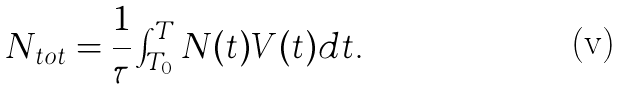<formula> <loc_0><loc_0><loc_500><loc_500>N _ { t o t } = \frac { 1 } { \tau } \int ^ { T } _ { T _ { 0 } } N ( t ) V ( t ) d t .</formula> 